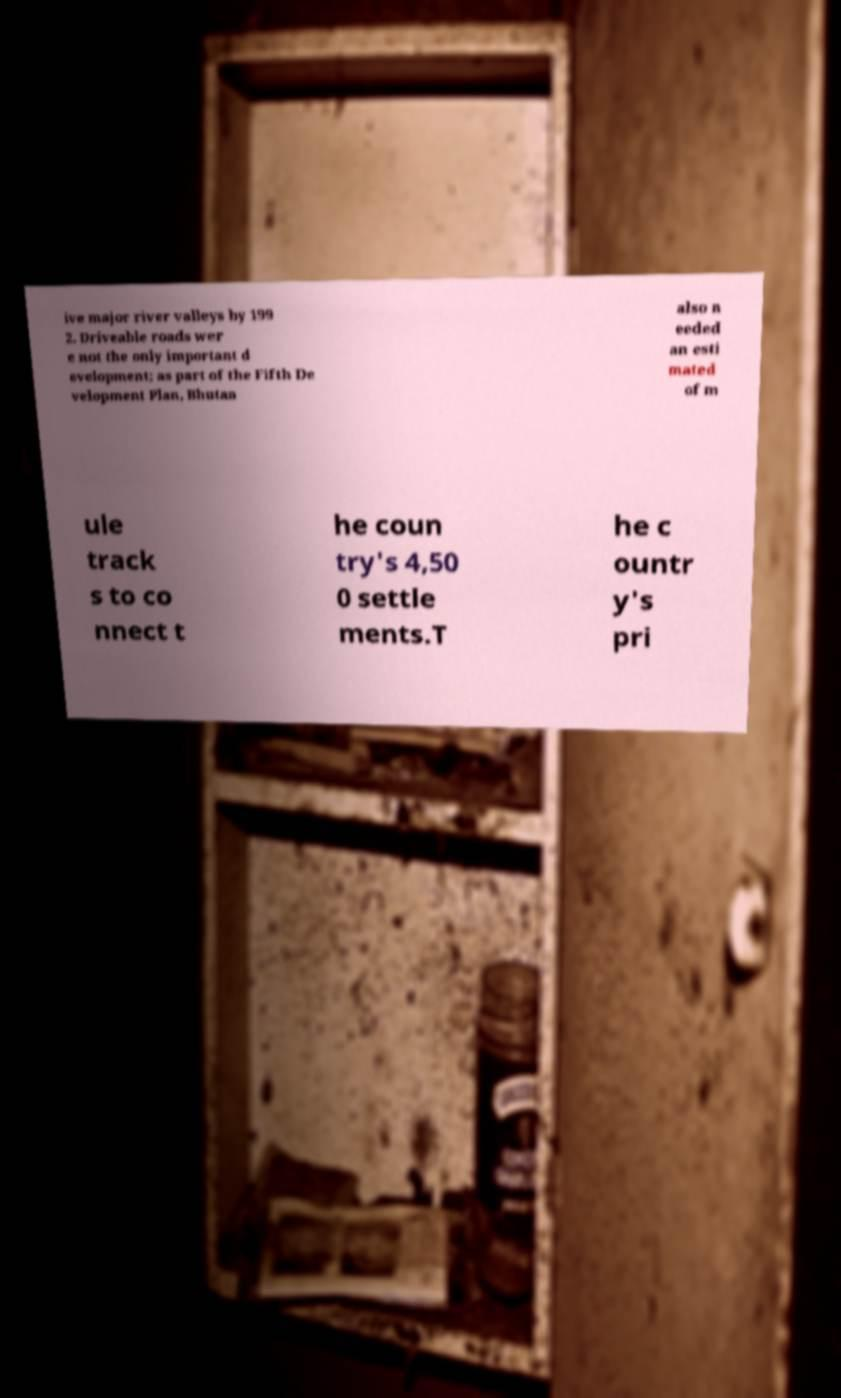There's text embedded in this image that I need extracted. Can you transcribe it verbatim? ive major river valleys by 199 2. Driveable roads wer e not the only important d evelopment; as part of the Fifth De velopment Plan, Bhutan also n eeded an esti mated of m ule track s to co nnect t he coun try's 4,50 0 settle ments.T he c ountr y's pri 